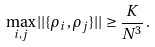Convert formula to latex. <formula><loc_0><loc_0><loc_500><loc_500>\max _ { i , j } | | \{ \rho _ { i } , \rho _ { j } \} | | \geq \frac { K } { N ^ { 3 } } \, .</formula> 